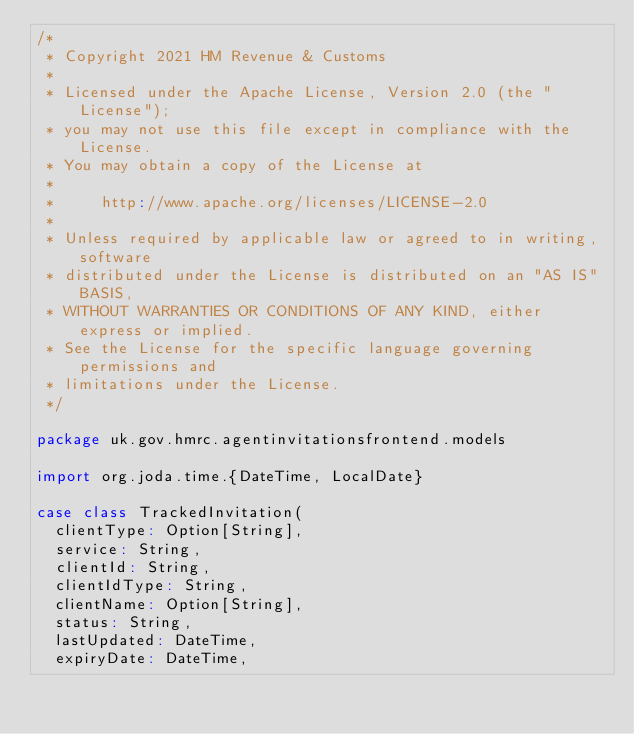Convert code to text. <code><loc_0><loc_0><loc_500><loc_500><_Scala_>/*
 * Copyright 2021 HM Revenue & Customs
 *
 * Licensed under the Apache License, Version 2.0 (the "License");
 * you may not use this file except in compliance with the License.
 * You may obtain a copy of the License at
 *
 *     http://www.apache.org/licenses/LICENSE-2.0
 *
 * Unless required by applicable law or agreed to in writing, software
 * distributed under the License is distributed on an "AS IS" BASIS,
 * WITHOUT WARRANTIES OR CONDITIONS OF ANY KIND, either express or implied.
 * See the License for the specific language governing permissions and
 * limitations under the License.
 */

package uk.gov.hmrc.agentinvitationsfrontend.models

import org.joda.time.{DateTime, LocalDate}

case class TrackedInvitation(
  clientType: Option[String],
  service: String,
  clientId: String,
  clientIdType: String,
  clientName: Option[String],
  status: String,
  lastUpdated: DateTime,
  expiryDate: DateTime,</code> 